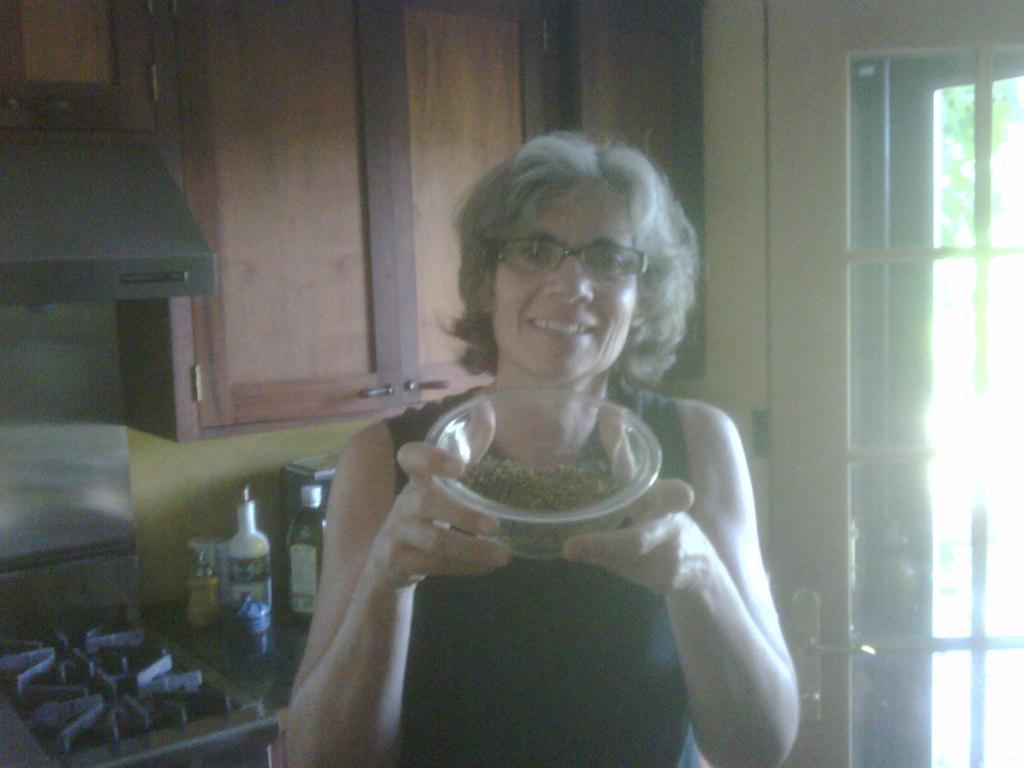Please provide a concise description of this image. In this picture we can see a woman holding a bowl in her hands and smiling. Behind this woman, we can see a gas stove, bottles and a grey object on a platform. We can see a wooden cupboard and other objects in the background. There is a door and a door handle visible on the right side. 